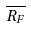Convert formula to latex. <formula><loc_0><loc_0><loc_500><loc_500>\overline { R _ { F } }</formula> 